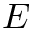Convert formula to latex. <formula><loc_0><loc_0><loc_500><loc_500>E</formula> 